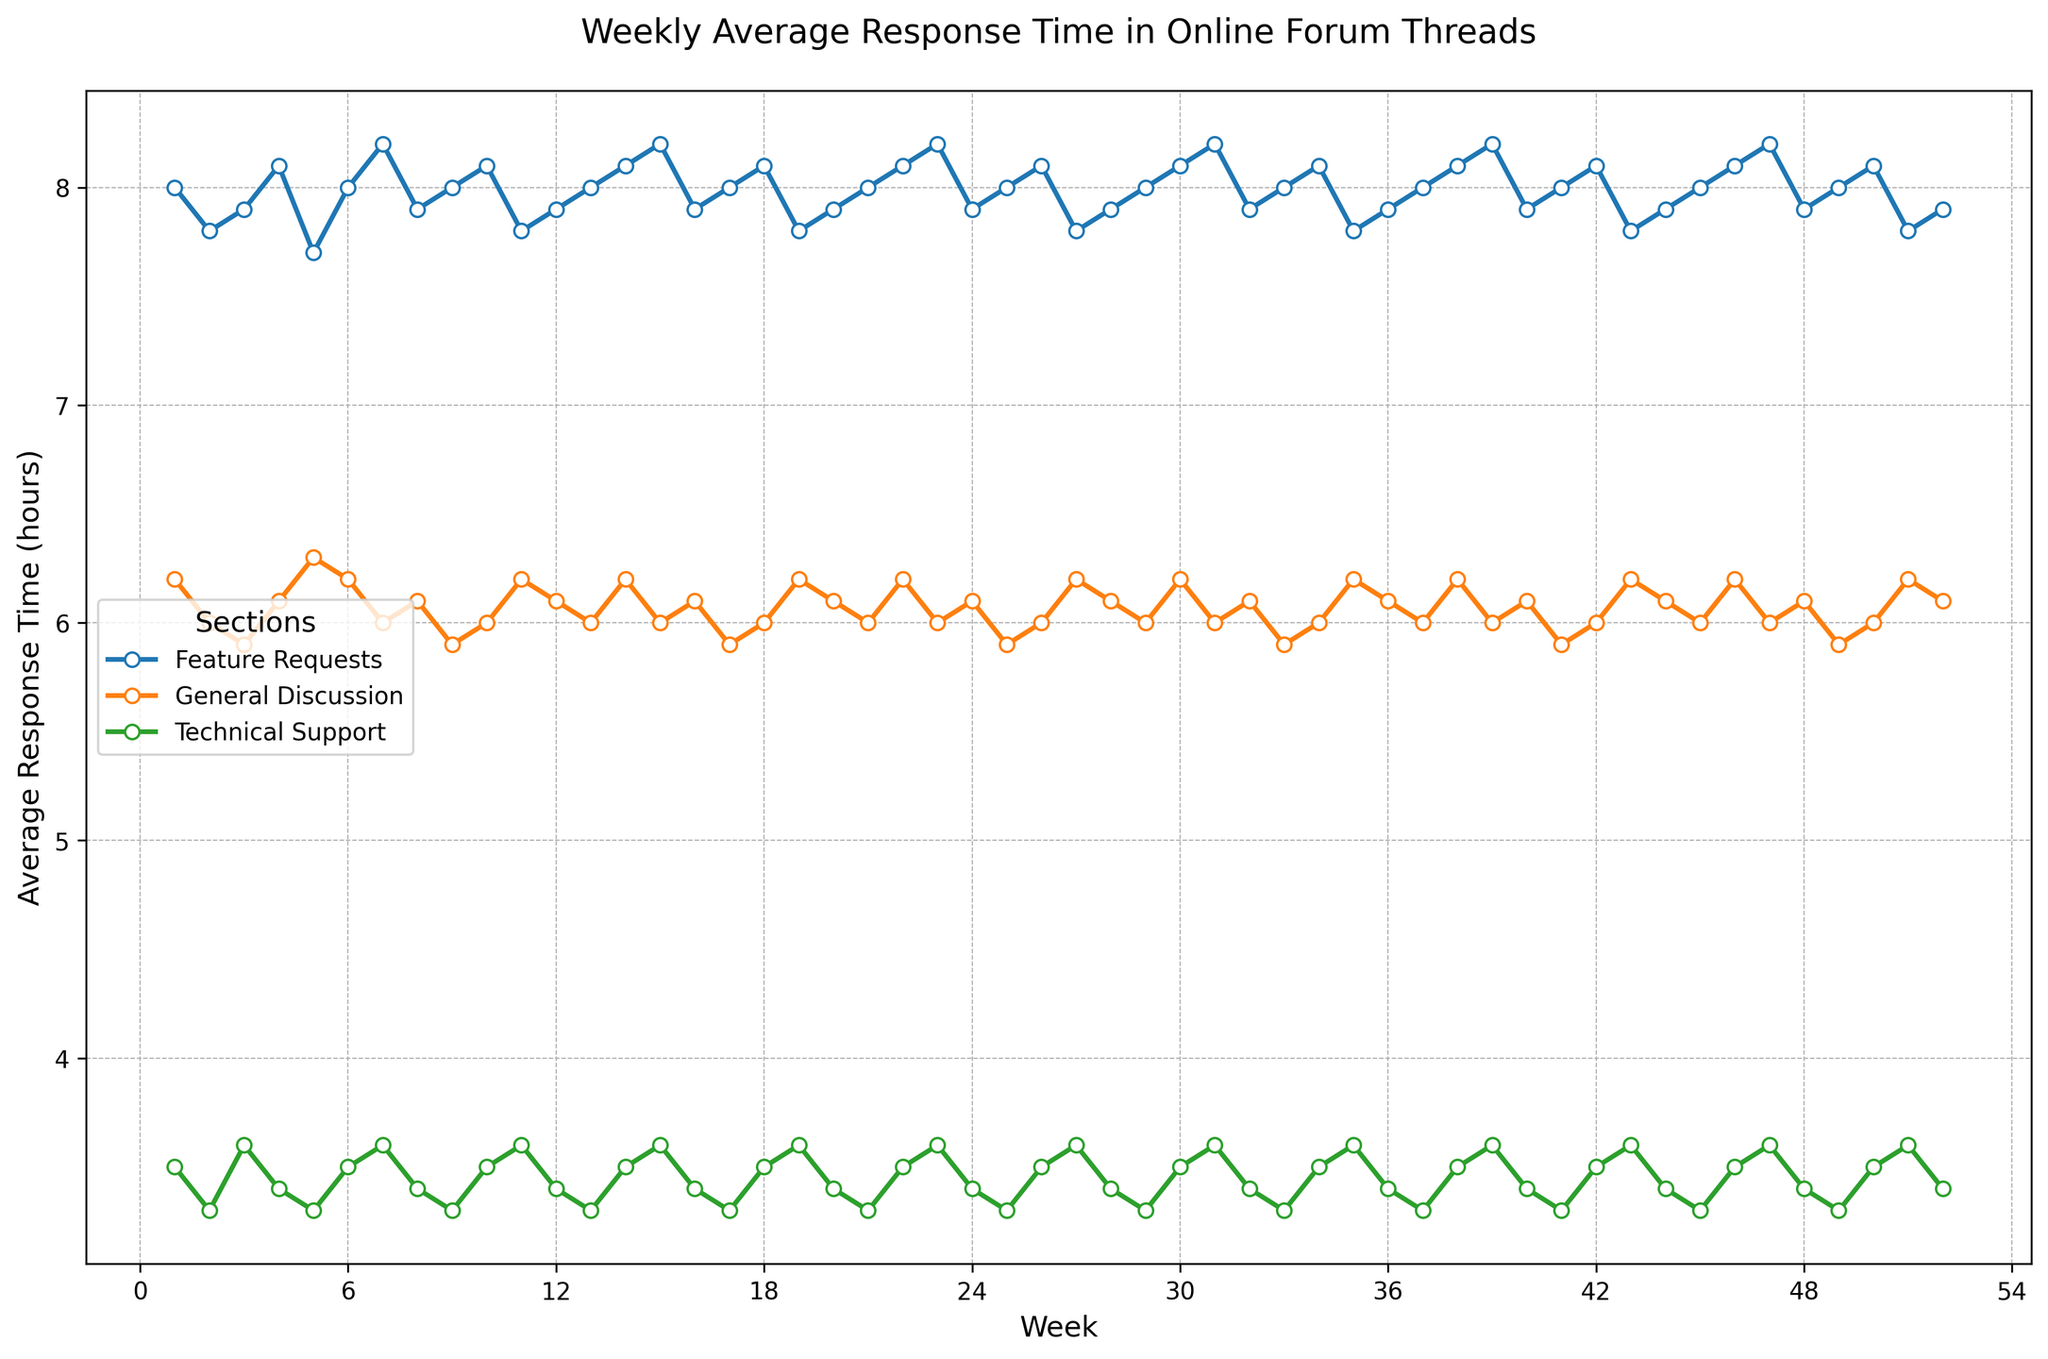What is the trend of the average response time in the Technical Support section from Week 1 to Week 52? By inspecting the line representing the Technical Support section, we see that it generally hovers around the 3.4-3.6 hour range, with minor fluctuations but no significant upward or downward trend.
Answer: Stable with minor fluctuations Which section has the highest average response time and during which week? By looking at the peak points in the plots for each section, the Feature Requests section has the highest average response time of 8.2 hours, occurring in weeks 7, 23, 31, 39, and 47.
Answer: Feature Requests, Weeks 7, 23, 31, 39, 47 Between General Discussion and Feature Requests, which section generally has a lower average response time? By comparing the lines for General Discussion and Feature Requests, we can see that General Discussion consistently has lower average response times than Feature Requests throughout the weeks.
Answer: General Discussion What is the average response time for the Technical Support section on Week 20 and Week 45? From Week 20, Technical Support's average response time is 3.4 hours, and for Week 45, it is 3.3 hours. To find the average: (3.4 + 3.3) / 2 = 3.35 hours.
Answer: 3.35 hours During which weeks did the General Discussion section have an average response time greater than 6 hours? By observing the plot, General Discussion's average response time is greater than 6 hours during Weeks 1, 5, 6, 10, 14, 19, 22, 27, 30, 34, 38, 43, 46, and 51.
Answer: Weeks 1, 5, 6, 10, 14, 19, 22, 27, 30, 34, 38, 43, 46, 51 Which section shows the most consistency in response time over the year and how is that identified visually? The Technical Support section shows the most consistency; this is detected by its almost flat line with very little variation over the weeks.
Answer: Technical Support, nearly flat line What is the range of the average response times for the General Discussion section throughout the year? The General Discussion section's response times range between 5.9 hours and 6.2 hours. The range is 6.2 - 5.9 = 0.3 hours.
Answer: 0.3 hours Identify the weeks where all sections (Technical Support, General Discussion, and Feature Requests) had the same average response time values. By checking the plot, no week shows all sections having the exact same average response times as each line is distinct for each week.
Answer: No such week 